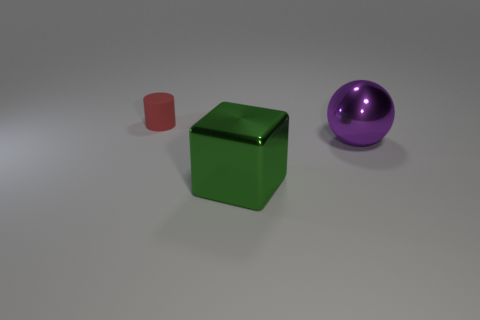Are the object that is left of the metal cube and the large purple ball made of the same material?
Make the answer very short. No. The large purple thing is what shape?
Give a very brief answer. Sphere. Is the number of large blocks that are left of the big purple metallic sphere greater than the number of large purple things?
Your answer should be compact. No. Is there anything else that has the same shape as the red matte object?
Give a very brief answer. No. The metal object behind the large green object has what shape?
Your answer should be compact. Sphere. There is a large purple metallic sphere; are there any big metal spheres to the left of it?
Make the answer very short. No. Are there any other things that have the same size as the red rubber cylinder?
Offer a very short reply. No. The big block that is made of the same material as the big purple ball is what color?
Provide a short and direct response. Green. There is a object that is right of the big green metallic block; does it have the same color as the object that is on the left side of the large green thing?
Your answer should be very brief. No. What number of blocks are either blue matte objects or green things?
Offer a terse response. 1. 